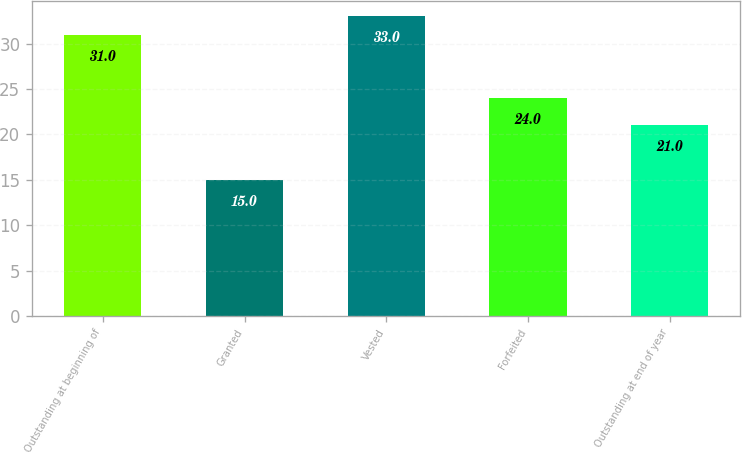Convert chart to OTSL. <chart><loc_0><loc_0><loc_500><loc_500><bar_chart><fcel>Outstanding at beginning of<fcel>Granted<fcel>Vested<fcel>Forfeited<fcel>Outstanding at end of year<nl><fcel>31<fcel>15<fcel>33<fcel>24<fcel>21<nl></chart> 